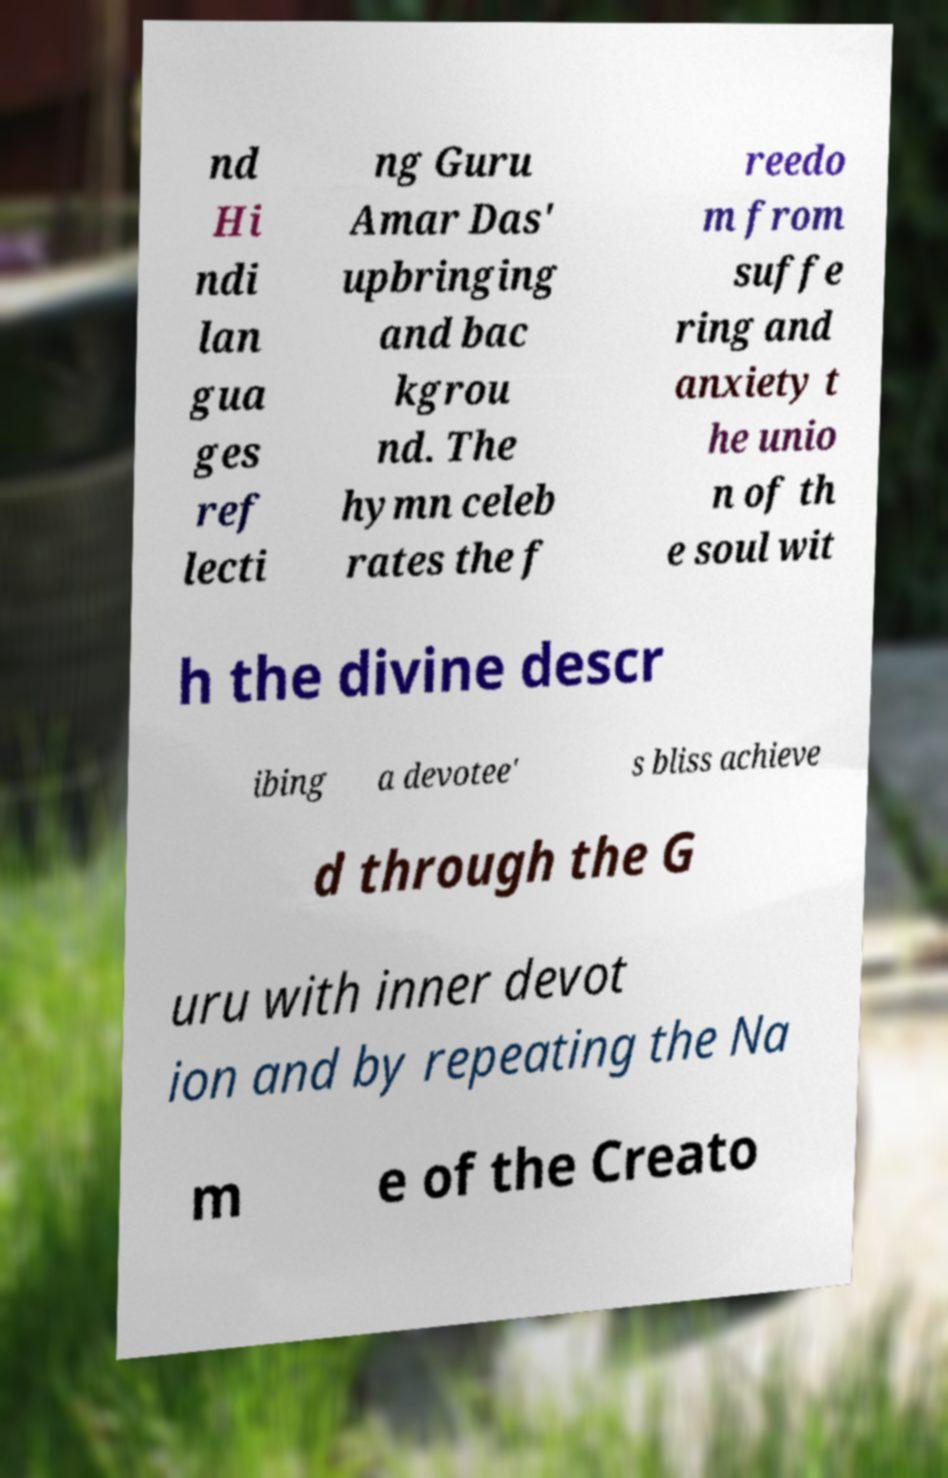Could you extract and type out the text from this image? nd Hi ndi lan gua ges ref lecti ng Guru Amar Das' upbringing and bac kgrou nd. The hymn celeb rates the f reedo m from suffe ring and anxiety t he unio n of th e soul wit h the divine descr ibing a devotee' s bliss achieve d through the G uru with inner devot ion and by repeating the Na m e of the Creato 